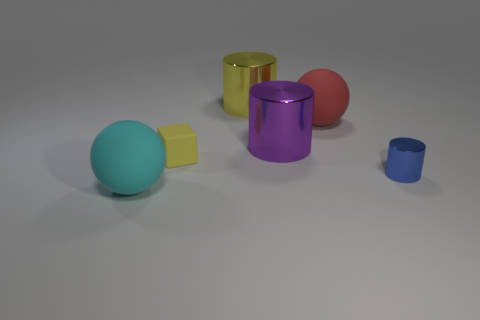What is the shape of the big metal thing that is the same color as the tiny matte cube?
Ensure brevity in your answer.  Cylinder. Are there any other things of the same color as the block?
Ensure brevity in your answer.  Yes. There is a shiny cylinder that is the same color as the small rubber thing; what size is it?
Your answer should be compact. Large. What number of other things are the same shape as the tiny shiny thing?
Your answer should be very brief. 2. Does the metal object that is behind the red object have the same color as the small matte object?
Offer a very short reply. Yes. Are there more cyan blocks than big cyan objects?
Keep it short and to the point. No. What color is the rubber sphere that is in front of the small blue metal object?
Offer a terse response. Cyan. Is the yellow shiny object the same shape as the tiny blue metal object?
Ensure brevity in your answer.  Yes. What is the color of the large thing that is to the right of the large yellow metal thing and in front of the big red matte ball?
Provide a succinct answer. Purple. There is a matte ball that is behind the cyan matte sphere; does it have the same size as the shiny cylinder in front of the tiny matte cube?
Provide a short and direct response. No. 